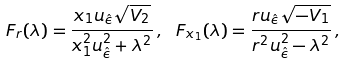Convert formula to latex. <formula><loc_0><loc_0><loc_500><loc_500>F _ { r } ( \lambda ) = \frac { x _ { 1 } u _ { \hat { \epsilon } } \sqrt { V _ { 2 } } } { x _ { 1 } ^ { 2 } u _ { \hat { \epsilon } } ^ { 2 } + \lambda ^ { 2 } } \, , \ F _ { x _ { 1 } } ( \lambda ) = \frac { r u _ { \hat { \epsilon } } \sqrt { - V _ { 1 } } } { r ^ { 2 } u _ { \hat { \epsilon } } ^ { 2 } - \lambda ^ { 2 } } \, ,</formula> 